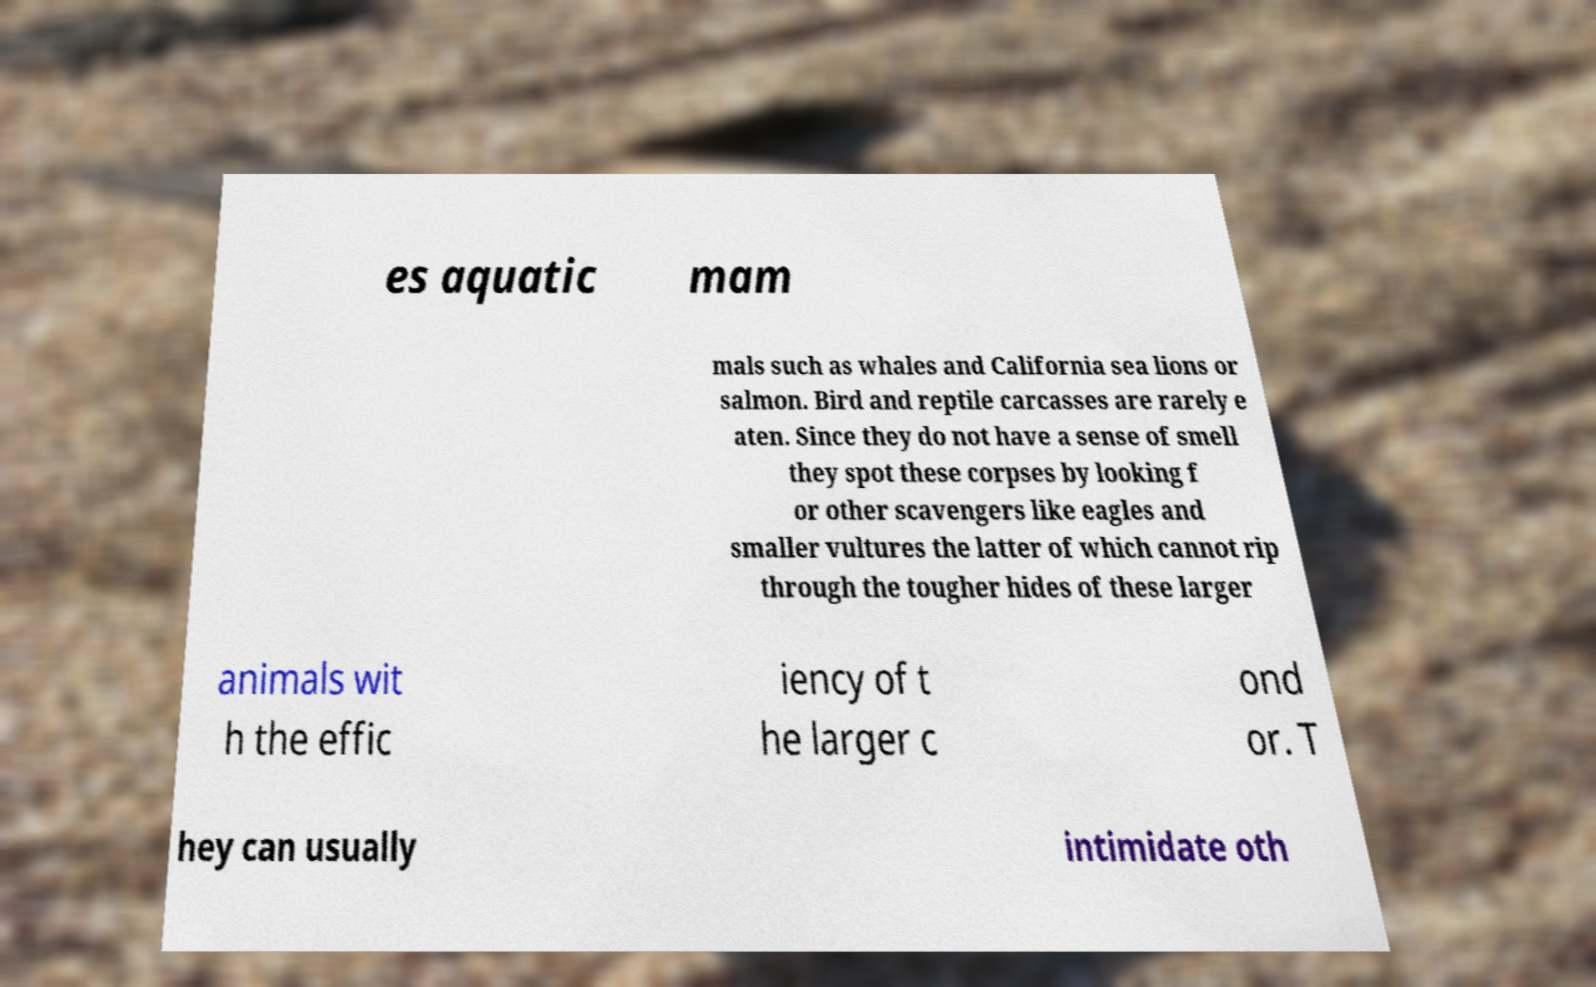Could you assist in decoding the text presented in this image and type it out clearly? es aquatic mam mals such as whales and California sea lions or salmon. Bird and reptile carcasses are rarely e aten. Since they do not have a sense of smell they spot these corpses by looking f or other scavengers like eagles and smaller vultures the latter of which cannot rip through the tougher hides of these larger animals wit h the effic iency of t he larger c ond or. T hey can usually intimidate oth 